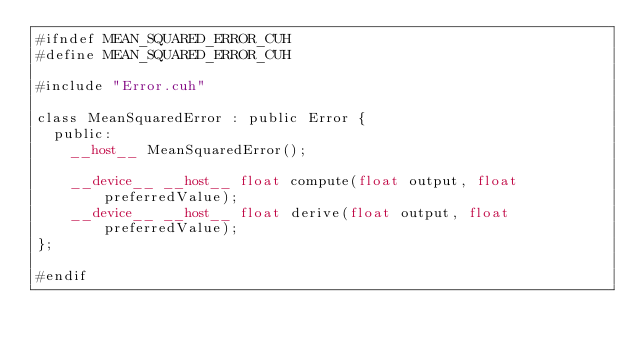<code> <loc_0><loc_0><loc_500><loc_500><_Cuda_>#ifndef MEAN_SQUARED_ERROR_CUH
#define MEAN_SQUARED_ERROR_CUH

#include "Error.cuh"

class MeanSquaredError : public Error {
	public:
		__host__ MeanSquaredError();

		__device__ __host__ float compute(float output, float preferredValue);
		__device__ __host__ float derive(float output, float preferredValue);
};

#endif</code> 